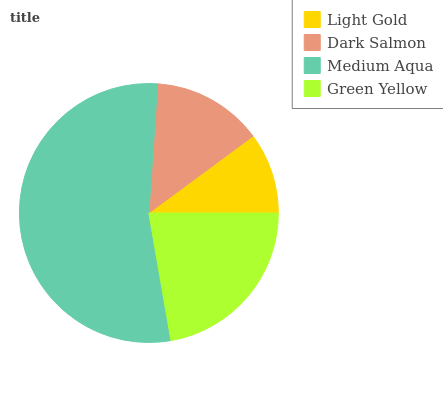Is Light Gold the minimum?
Answer yes or no. Yes. Is Medium Aqua the maximum?
Answer yes or no. Yes. Is Dark Salmon the minimum?
Answer yes or no. No. Is Dark Salmon the maximum?
Answer yes or no. No. Is Dark Salmon greater than Light Gold?
Answer yes or no. Yes. Is Light Gold less than Dark Salmon?
Answer yes or no. Yes. Is Light Gold greater than Dark Salmon?
Answer yes or no. No. Is Dark Salmon less than Light Gold?
Answer yes or no. No. Is Green Yellow the high median?
Answer yes or no. Yes. Is Dark Salmon the low median?
Answer yes or no. Yes. Is Light Gold the high median?
Answer yes or no. No. Is Green Yellow the low median?
Answer yes or no. No. 